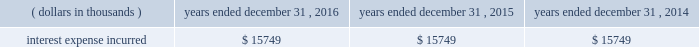During the fixed rate interest period from may 3 , 2007 through may 14 , 2017 , interest will be at the annual rate of 6.6% ( 6.6 % ) , payable semi-annually in arrears on november 15 and may 15 of each year , commencing on november 15 , 2007 , subject to holdings 2019 right to defer interest on one or more occasions for up to ten consecutive years .
During the floating rate interest period from may 15 , 2017 through maturity , interest will be based on the 3 month libor plus 238.5 basis points , reset quarterly , payable quarterly in arrears on february 15 , may 15 , august 15 and november 15 of each year , subject to holdings 2019 right to defer interest on one or more occasions for up to ten consecutive years .
Deferred interest will accumulate interest at the applicable rate compounded semi-annually for periods prior to may 15 , 2017 , and compounded quarterly for periods from and including may 15 , 2017 .
Holdings can redeem the long term subordinated notes prior to may 15 , 2017 , in whole but not in part at the applicable redemption price , which will equal the greater of ( a ) 100% ( 100 % ) of the principal amount being redeemed and ( b ) the present value of the principal payment on may 15 , 2017 and scheduled payments of interest that would have accrued from the redemption date to may 15 , 2017 on the long term subordinated notes being redeemed , discounted to the redemption date on a semi-annual basis at a discount rate equal to the treasury rate plus an applicable spread of either 0.25% ( 0.25 % ) or 0.50% ( 0.50 % ) , in each case plus accrued and unpaid interest .
Holdings may redeem the long term subordinated notes on or after may 15 , 2017 , in whole or in part at 100% ( 100 % ) of the principal amount plus accrued and unpaid interest ; however , redemption on or after the scheduled maturity date and prior to may 1 , 2047 is subject to a replacement capital covenant .
This covenant is for the benefit of certain senior note holders and it mandates that holdings receive proceeds from the sale of another subordinated debt issue , of at least similar size , before it may redeem the subordinated notes .
Effective upon the maturity of the company 2019s 5.40% ( 5.40 % ) senior notes on october 15 , 2014 , the company 2019s 4.868% ( 4.868 % ) senior notes , due on june 1 , 2044 , have become the company 2019s long term indebtedness that ranks senior to the long term subordinated notes .
On march 19 , 2009 , group announced the commencement of a cash tender offer for any and all of the 6.60% ( 6.60 % ) fixed to floating rate long term subordinated notes .
Upon expiration of the tender offer , the company had reduced its outstanding debt by $ 161441 thousand .
Interest expense incurred in connection with these long term subordinated notes is as follows for the periods indicated: .
Collateralized reinsurance and trust agreements certain subsidiaries of group have established trust agreements , which effectively use the company 2019s investments as collateral , as security for assumed losses payable to certain non-affiliated ceding companies .
At december 31 , 2016 , the total amount on deposit in trust accounts was $ 466029 thousand .
The company reinsures some of its catastrophe exposures with the segregated accounts of mt .
Logan re .
Mt .
Logan re is a class 3 insurer registered in bermuda effective february 27 , 2013 under the segregated accounts companies act 2000 and 100% ( 100 % ) of the voting common shares are owned by group .
Separate segregated accounts for mt .
Logan re began being established effective july 1 , 2013 and non-voting , redeemable preferred shares have been issued to capitalize the segregated accounts .
Each segregated account invests predominately in a diversified set of catastrophe exposures , diversified by risk/peril and across different geographic regions globally. .
What was the total interest expense incurred associated with the long term subordinated notes from 2014 to 2016 in thousands of dollars? 
Computations: (15749 * 3)
Answer: 47247.0. 